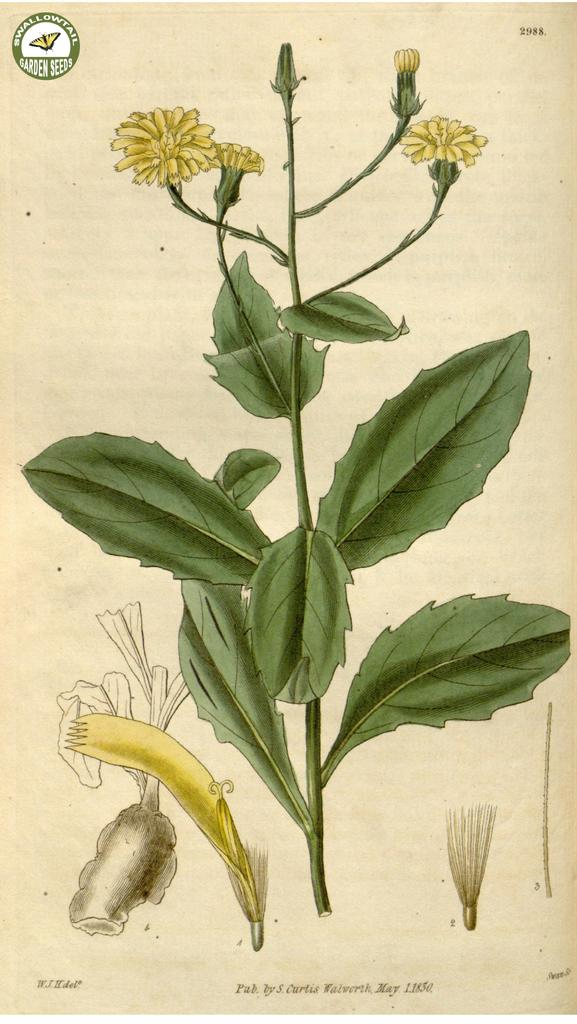What is depicted in the sketch in the image? The image contains a sketch of a plant. What features can be observed on the plant in the sketch? The plant has flowers and buds. What can be seen at the bottom of the picture? There are parts of a flower in the bottom of the picture. What type of lunch is being served to the girls in the image? There are no girls or lunch in the image. --- Facts: 1. There is a person sitting on a bench in the image. 2. The person is reading a book. 3. The bench is located in a park. 4. There are trees in the background of the image. 5. The sky is visible in the background of the image. Absurd Topics: elephant, dance, ocean Conversation: What is the person in the image doing? The person is sitting on a bench in the image. What activity is the person engaged in while sitting on the bench? The person is reading a book. Where is the bench located? The bench is located in a park. What can be seen in the background of the image? There are trees and the sky visible in the background of the image. Reasoning: Let's think step by step in order to produce the conversation. We start by identifying the main subject of the image, which is the person sitting on the bench. Then, we describe the specific activity the person is engaged in, which is reading a book. Next, we mention the location of the bench, which is in a park. Finally, we describe the background of the image, which includes trees and the sky. Absurd Question/Answer: Can you see an elephant dancing in the ocean in the image? No, there is no elephant, dancing, or ocean present in the image. 